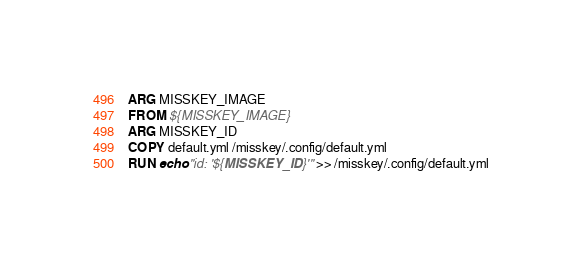<code> <loc_0><loc_0><loc_500><loc_500><_Dockerfile_>ARG MISSKEY_IMAGE
FROM ${MISSKEY_IMAGE}
ARG MISSKEY_ID
COPY default.yml /misskey/.config/default.yml
RUN echo "id: '${MISSKEY_ID}'" >> /misskey/.config/default.yml
</code> 